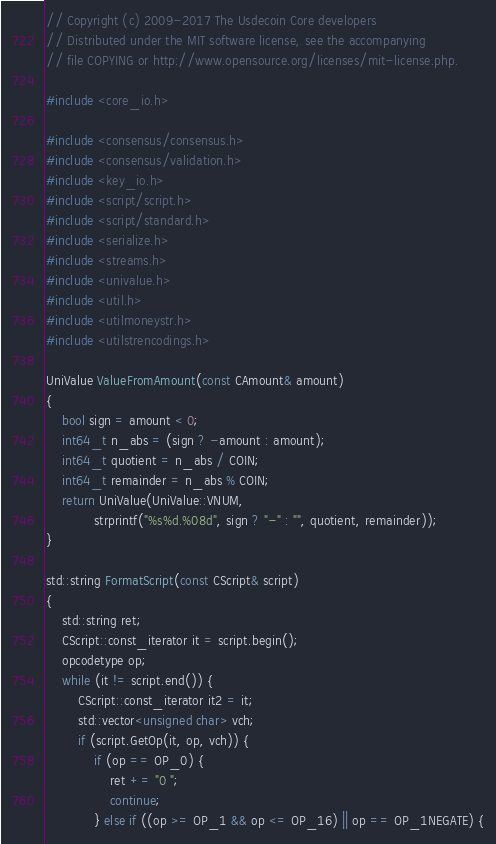Convert code to text. <code><loc_0><loc_0><loc_500><loc_500><_C++_>// Copyright (c) 2009-2017 The Usdecoin Core developers
// Distributed under the MIT software license, see the accompanying
// file COPYING or http://www.opensource.org/licenses/mit-license.php.

#include <core_io.h>

#include <consensus/consensus.h>
#include <consensus/validation.h>
#include <key_io.h>
#include <script/script.h>
#include <script/standard.h>
#include <serialize.h>
#include <streams.h>
#include <univalue.h>
#include <util.h>
#include <utilmoneystr.h>
#include <utilstrencodings.h>

UniValue ValueFromAmount(const CAmount& amount)
{
    bool sign = amount < 0;
    int64_t n_abs = (sign ? -amount : amount);
    int64_t quotient = n_abs / COIN;
    int64_t remainder = n_abs % COIN;
    return UniValue(UniValue::VNUM,
            strprintf("%s%d.%08d", sign ? "-" : "", quotient, remainder));
}

std::string FormatScript(const CScript& script)
{
    std::string ret;
    CScript::const_iterator it = script.begin();
    opcodetype op;
    while (it != script.end()) {
        CScript::const_iterator it2 = it;
        std::vector<unsigned char> vch;
        if (script.GetOp(it, op, vch)) {
            if (op == OP_0) {
                ret += "0 ";
                continue;
            } else if ((op >= OP_1 && op <= OP_16) || op == OP_1NEGATE) {</code> 